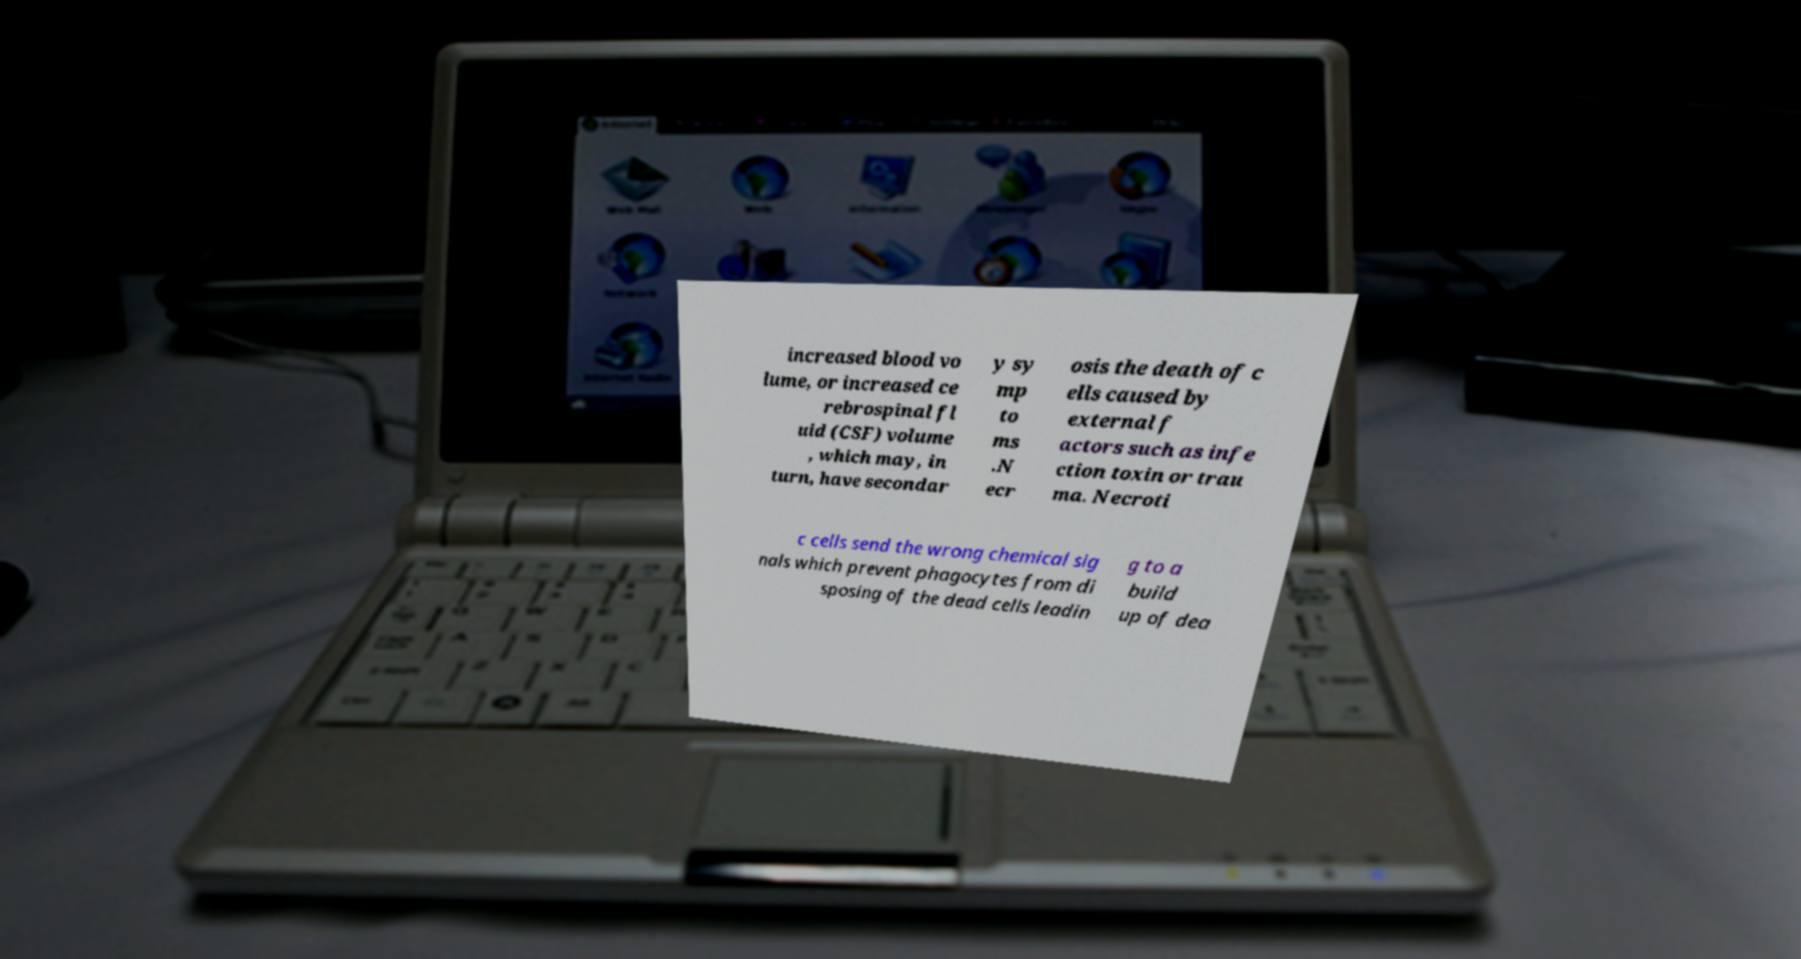There's text embedded in this image that I need extracted. Can you transcribe it verbatim? increased blood vo lume, or increased ce rebrospinal fl uid (CSF) volume , which may, in turn, have secondar y sy mp to ms .N ecr osis the death of c ells caused by external f actors such as infe ction toxin or trau ma. Necroti c cells send the wrong chemical sig nals which prevent phagocytes from di sposing of the dead cells leadin g to a build up of dea 